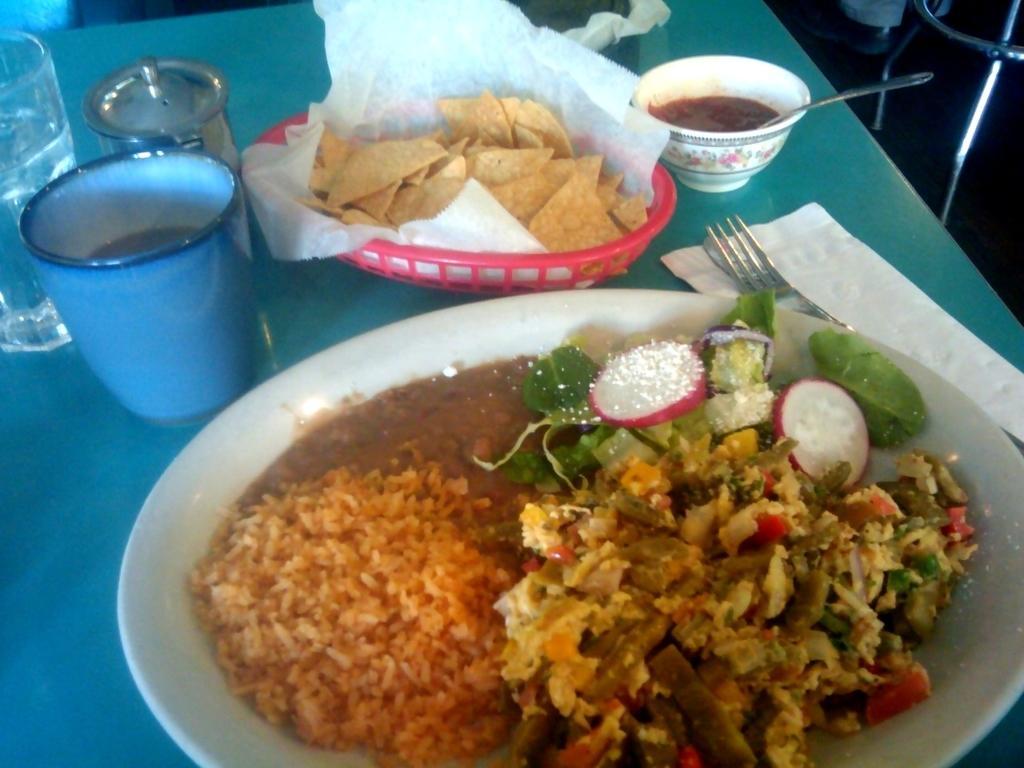Describe this image in one or two sentences. In this image, we can see a table, there is a plate on the table. We can see some food on the plate, there are some glasses, tissue paper and a fork on the table. 